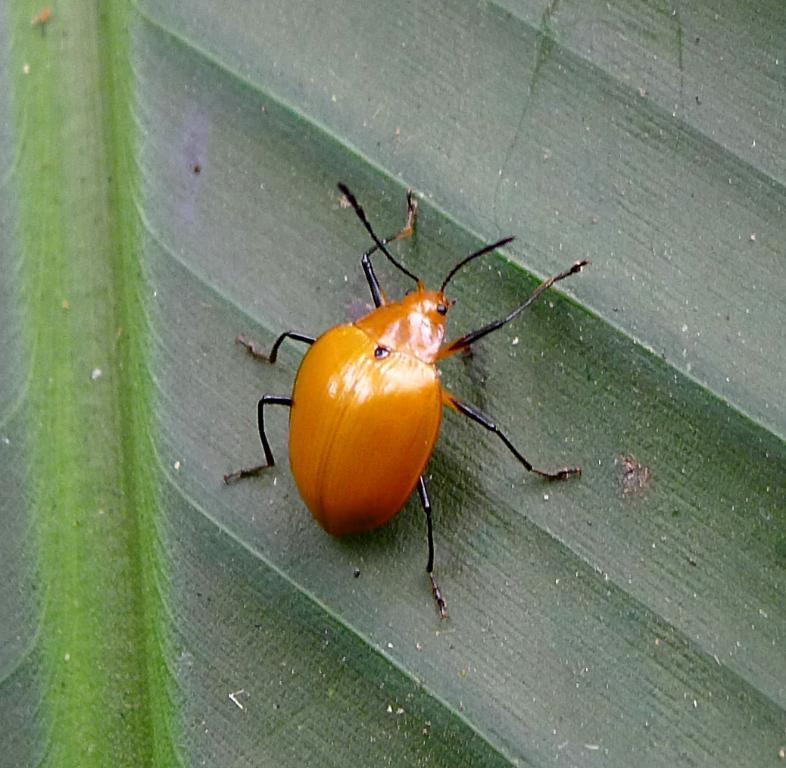Could you give a brief overview of what you see in this image? In the image in the center we can see one green color leaf. On leaf,we can see one insect,which is yellow and black color. 